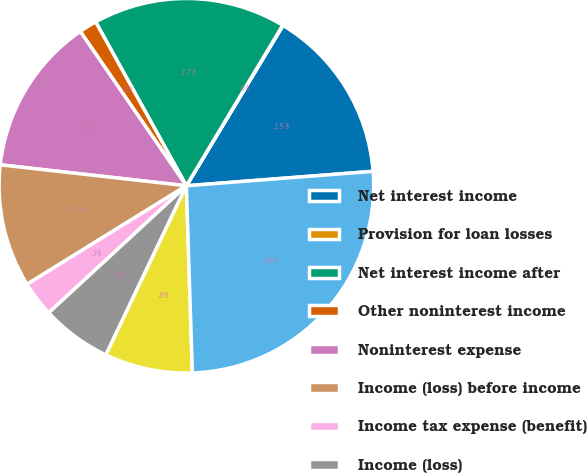Convert chart to OTSL. <chart><loc_0><loc_0><loc_500><loc_500><pie_chart><fcel>Net interest income<fcel>Provision for loan losses<fcel>Net interest income after<fcel>Other noninterest income<fcel>Noninterest expense<fcel>Income (loss) before income<fcel>Income tax expense (benefit)<fcel>Income (loss)<fcel>Net income (loss) applicable<fcel>Total assets<nl><fcel>15.14%<fcel>0.03%<fcel>16.65%<fcel>1.54%<fcel>13.63%<fcel>10.6%<fcel>3.05%<fcel>6.07%<fcel>7.58%<fcel>25.72%<nl></chart> 